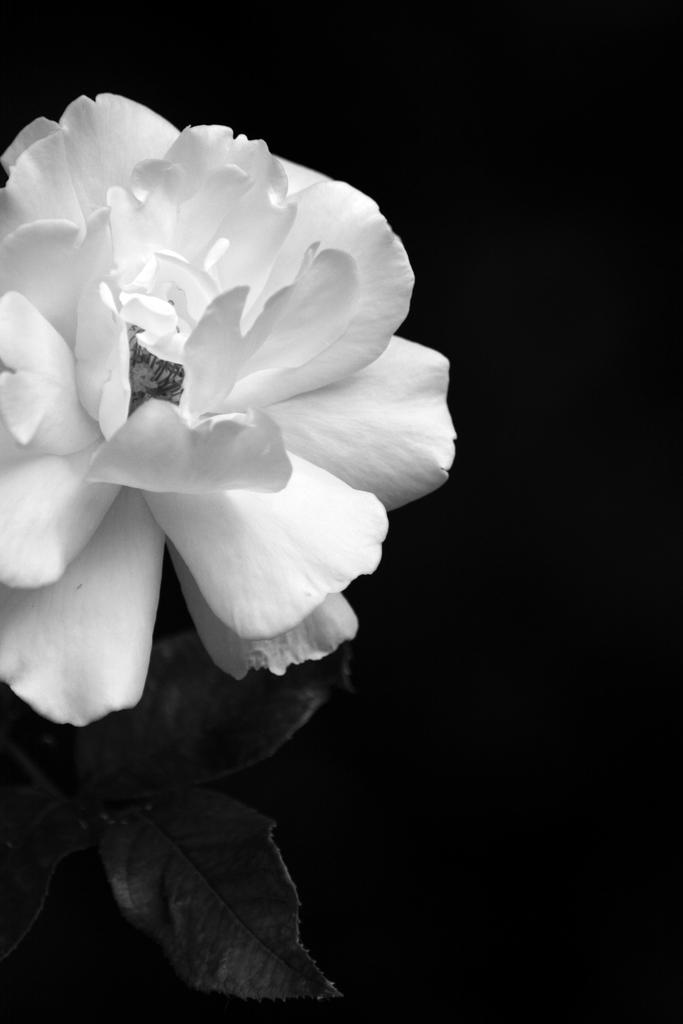What is the main subject of the image? There is a flower in the image. What color is the flower? The flower is white in color. How is the image presented in terms of color? The image is black and white. What time of day is depicted in the image? The image does not depict a specific time of day, as it is a black and white image of a white flower. Is there a hose visible in the image? There is no hose present in the image; it only features a white flower. 